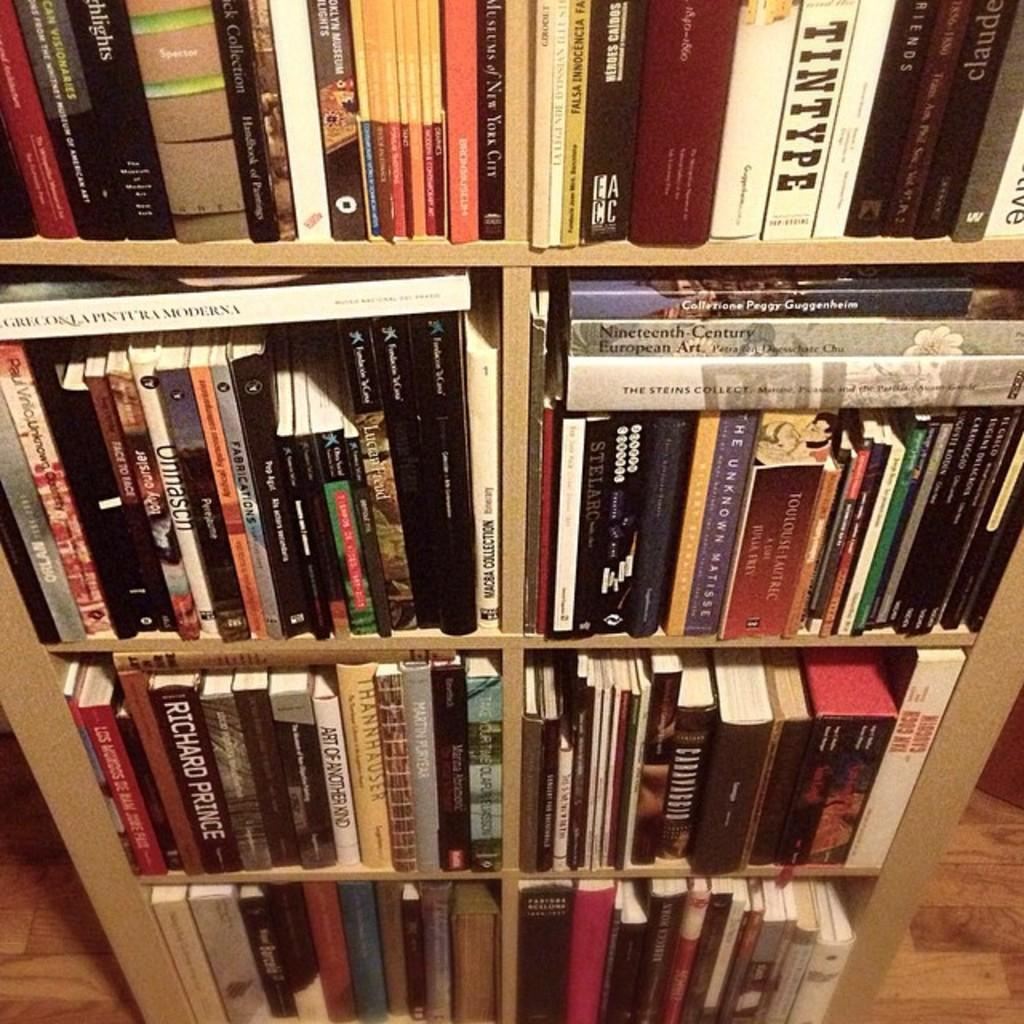<image>
Render a clear and concise summary of the photo. The tall, narrow bookcase houses a large number of books, including titles like Nineteenth Century European Art and Richard Prince. 